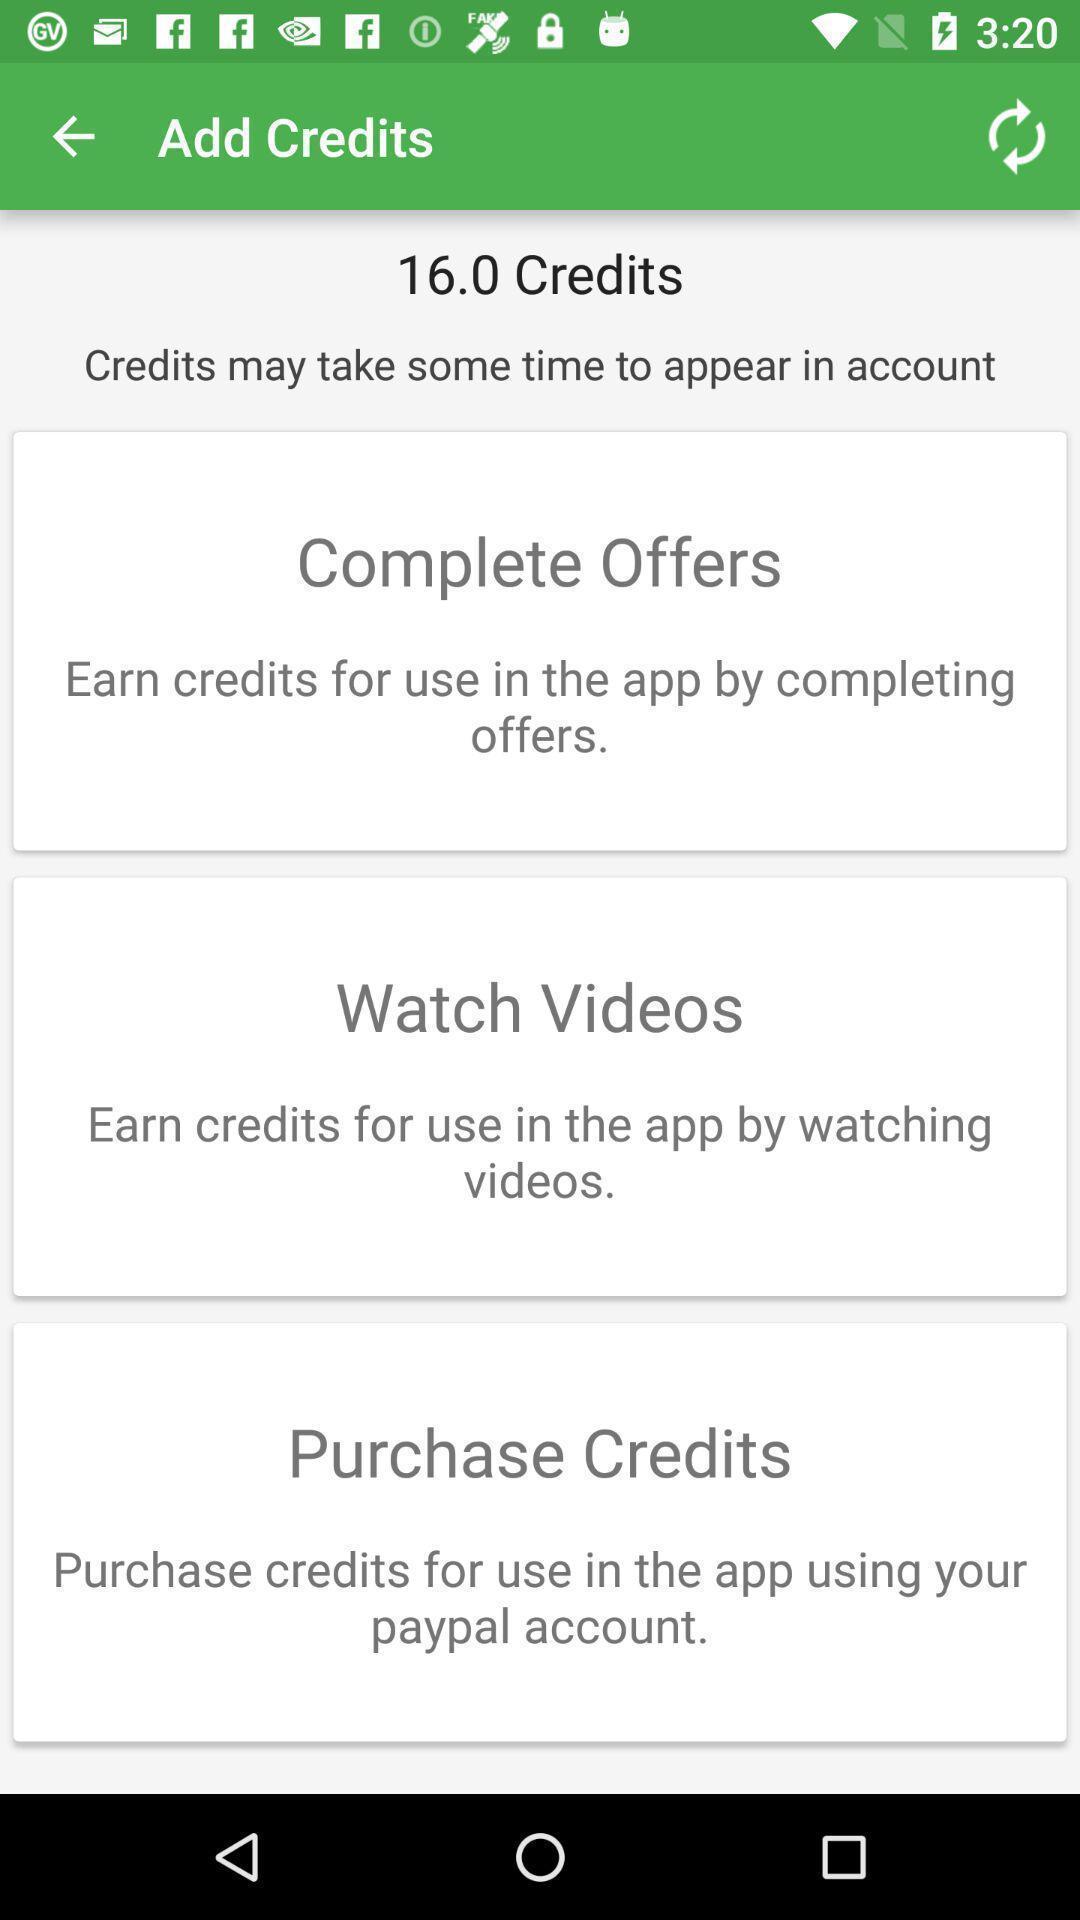Tell me what you see in this picture. Screen displaying number of credits. 